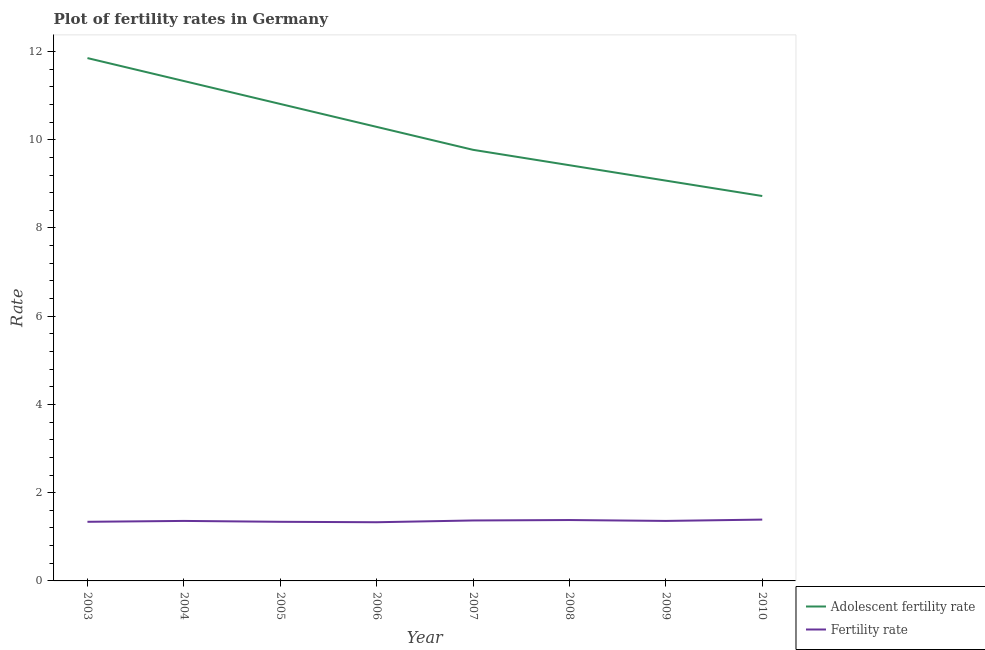How many different coloured lines are there?
Make the answer very short. 2. Is the number of lines equal to the number of legend labels?
Make the answer very short. Yes. What is the adolescent fertility rate in 2008?
Your answer should be compact. 9.42. Across all years, what is the maximum adolescent fertility rate?
Ensure brevity in your answer.  11.85. Across all years, what is the minimum adolescent fertility rate?
Offer a very short reply. 8.72. In which year was the fertility rate maximum?
Keep it short and to the point. 2010. In which year was the adolescent fertility rate minimum?
Make the answer very short. 2010. What is the total fertility rate in the graph?
Your answer should be very brief. 10.87. What is the difference between the adolescent fertility rate in 2005 and that in 2009?
Provide a short and direct response. 1.74. What is the difference between the adolescent fertility rate in 2003 and the fertility rate in 2008?
Ensure brevity in your answer.  10.47. What is the average adolescent fertility rate per year?
Keep it short and to the point. 10.16. In the year 2008, what is the difference between the adolescent fertility rate and fertility rate?
Your response must be concise. 8.04. In how many years, is the adolescent fertility rate greater than 6.8?
Ensure brevity in your answer.  8. What is the ratio of the adolescent fertility rate in 2004 to that in 2010?
Offer a terse response. 1.3. What is the difference between the highest and the second highest adolescent fertility rate?
Give a very brief answer. 0.52. What is the difference between the highest and the lowest adolescent fertility rate?
Offer a very short reply. 3.13. Is the sum of the fertility rate in 2008 and 2009 greater than the maximum adolescent fertility rate across all years?
Your response must be concise. No. Is the fertility rate strictly less than the adolescent fertility rate over the years?
Provide a succinct answer. Yes. Are the values on the major ticks of Y-axis written in scientific E-notation?
Your response must be concise. No. Does the graph contain any zero values?
Make the answer very short. No. What is the title of the graph?
Keep it short and to the point. Plot of fertility rates in Germany. Does "Girls" appear as one of the legend labels in the graph?
Ensure brevity in your answer.  No. What is the label or title of the X-axis?
Offer a terse response. Year. What is the label or title of the Y-axis?
Ensure brevity in your answer.  Rate. What is the Rate in Adolescent fertility rate in 2003?
Offer a very short reply. 11.85. What is the Rate in Fertility rate in 2003?
Keep it short and to the point. 1.34. What is the Rate of Adolescent fertility rate in 2004?
Offer a terse response. 11.33. What is the Rate of Fertility rate in 2004?
Ensure brevity in your answer.  1.36. What is the Rate in Adolescent fertility rate in 2005?
Offer a very short reply. 10.81. What is the Rate in Fertility rate in 2005?
Your answer should be very brief. 1.34. What is the Rate of Adolescent fertility rate in 2006?
Give a very brief answer. 10.29. What is the Rate of Fertility rate in 2006?
Provide a succinct answer. 1.33. What is the Rate in Adolescent fertility rate in 2007?
Ensure brevity in your answer.  9.77. What is the Rate in Fertility rate in 2007?
Offer a very short reply. 1.37. What is the Rate in Adolescent fertility rate in 2008?
Your response must be concise. 9.42. What is the Rate of Fertility rate in 2008?
Make the answer very short. 1.38. What is the Rate in Adolescent fertility rate in 2009?
Provide a short and direct response. 9.07. What is the Rate in Fertility rate in 2009?
Ensure brevity in your answer.  1.36. What is the Rate in Adolescent fertility rate in 2010?
Make the answer very short. 8.72. What is the Rate of Fertility rate in 2010?
Ensure brevity in your answer.  1.39. Across all years, what is the maximum Rate of Adolescent fertility rate?
Your response must be concise. 11.85. Across all years, what is the maximum Rate of Fertility rate?
Give a very brief answer. 1.39. Across all years, what is the minimum Rate of Adolescent fertility rate?
Offer a terse response. 8.72. Across all years, what is the minimum Rate in Fertility rate?
Provide a short and direct response. 1.33. What is the total Rate of Adolescent fertility rate in the graph?
Your answer should be very brief. 81.27. What is the total Rate of Fertility rate in the graph?
Ensure brevity in your answer.  10.87. What is the difference between the Rate in Adolescent fertility rate in 2003 and that in 2004?
Provide a succinct answer. 0.52. What is the difference between the Rate in Fertility rate in 2003 and that in 2004?
Provide a succinct answer. -0.02. What is the difference between the Rate of Adolescent fertility rate in 2003 and that in 2005?
Provide a short and direct response. 1.04. What is the difference between the Rate of Fertility rate in 2003 and that in 2005?
Provide a succinct answer. 0. What is the difference between the Rate of Adolescent fertility rate in 2003 and that in 2006?
Provide a succinct answer. 1.56. What is the difference between the Rate in Fertility rate in 2003 and that in 2006?
Offer a very short reply. 0.01. What is the difference between the Rate of Adolescent fertility rate in 2003 and that in 2007?
Keep it short and to the point. 2.08. What is the difference between the Rate in Fertility rate in 2003 and that in 2007?
Make the answer very short. -0.03. What is the difference between the Rate of Adolescent fertility rate in 2003 and that in 2008?
Your answer should be very brief. 2.43. What is the difference between the Rate in Fertility rate in 2003 and that in 2008?
Make the answer very short. -0.04. What is the difference between the Rate in Adolescent fertility rate in 2003 and that in 2009?
Your answer should be compact. 2.78. What is the difference between the Rate of Fertility rate in 2003 and that in 2009?
Provide a short and direct response. -0.02. What is the difference between the Rate in Adolescent fertility rate in 2003 and that in 2010?
Provide a short and direct response. 3.13. What is the difference between the Rate of Adolescent fertility rate in 2004 and that in 2005?
Make the answer very short. 0.52. What is the difference between the Rate of Adolescent fertility rate in 2004 and that in 2006?
Give a very brief answer. 1.04. What is the difference between the Rate of Adolescent fertility rate in 2004 and that in 2007?
Offer a very short reply. 1.56. What is the difference between the Rate of Fertility rate in 2004 and that in 2007?
Your response must be concise. -0.01. What is the difference between the Rate of Adolescent fertility rate in 2004 and that in 2008?
Keep it short and to the point. 1.91. What is the difference between the Rate in Fertility rate in 2004 and that in 2008?
Provide a short and direct response. -0.02. What is the difference between the Rate of Adolescent fertility rate in 2004 and that in 2009?
Keep it short and to the point. 2.26. What is the difference between the Rate of Fertility rate in 2004 and that in 2009?
Your answer should be very brief. 0. What is the difference between the Rate in Adolescent fertility rate in 2004 and that in 2010?
Your answer should be very brief. 2.61. What is the difference between the Rate of Fertility rate in 2004 and that in 2010?
Make the answer very short. -0.03. What is the difference between the Rate in Adolescent fertility rate in 2005 and that in 2006?
Your answer should be very brief. 0.52. What is the difference between the Rate of Fertility rate in 2005 and that in 2006?
Provide a succinct answer. 0.01. What is the difference between the Rate of Adolescent fertility rate in 2005 and that in 2007?
Your response must be concise. 1.04. What is the difference between the Rate in Fertility rate in 2005 and that in 2007?
Provide a short and direct response. -0.03. What is the difference between the Rate in Adolescent fertility rate in 2005 and that in 2008?
Make the answer very short. 1.39. What is the difference between the Rate in Fertility rate in 2005 and that in 2008?
Give a very brief answer. -0.04. What is the difference between the Rate of Adolescent fertility rate in 2005 and that in 2009?
Your answer should be very brief. 1.74. What is the difference between the Rate in Fertility rate in 2005 and that in 2009?
Make the answer very short. -0.02. What is the difference between the Rate in Adolescent fertility rate in 2005 and that in 2010?
Provide a succinct answer. 2.09. What is the difference between the Rate of Fertility rate in 2005 and that in 2010?
Provide a short and direct response. -0.05. What is the difference between the Rate in Adolescent fertility rate in 2006 and that in 2007?
Ensure brevity in your answer.  0.52. What is the difference between the Rate in Fertility rate in 2006 and that in 2007?
Your answer should be very brief. -0.04. What is the difference between the Rate in Adolescent fertility rate in 2006 and that in 2008?
Your response must be concise. 0.87. What is the difference between the Rate of Adolescent fertility rate in 2006 and that in 2009?
Give a very brief answer. 1.22. What is the difference between the Rate of Fertility rate in 2006 and that in 2009?
Give a very brief answer. -0.03. What is the difference between the Rate of Adolescent fertility rate in 2006 and that in 2010?
Make the answer very short. 1.57. What is the difference between the Rate of Fertility rate in 2006 and that in 2010?
Your answer should be compact. -0.06. What is the difference between the Rate of Adolescent fertility rate in 2007 and that in 2008?
Provide a succinct answer. 0.35. What is the difference between the Rate in Fertility rate in 2007 and that in 2008?
Provide a succinct answer. -0.01. What is the difference between the Rate in Adolescent fertility rate in 2007 and that in 2009?
Keep it short and to the point. 0.7. What is the difference between the Rate in Adolescent fertility rate in 2007 and that in 2010?
Your answer should be compact. 1.05. What is the difference between the Rate of Fertility rate in 2007 and that in 2010?
Offer a terse response. -0.02. What is the difference between the Rate in Adolescent fertility rate in 2008 and that in 2009?
Provide a succinct answer. 0.35. What is the difference between the Rate of Adolescent fertility rate in 2008 and that in 2010?
Your response must be concise. 0.7. What is the difference between the Rate in Fertility rate in 2008 and that in 2010?
Provide a succinct answer. -0.01. What is the difference between the Rate of Adolescent fertility rate in 2009 and that in 2010?
Offer a very short reply. 0.35. What is the difference between the Rate in Fertility rate in 2009 and that in 2010?
Make the answer very short. -0.03. What is the difference between the Rate of Adolescent fertility rate in 2003 and the Rate of Fertility rate in 2004?
Provide a short and direct response. 10.49. What is the difference between the Rate in Adolescent fertility rate in 2003 and the Rate in Fertility rate in 2005?
Keep it short and to the point. 10.51. What is the difference between the Rate of Adolescent fertility rate in 2003 and the Rate of Fertility rate in 2006?
Your answer should be very brief. 10.52. What is the difference between the Rate of Adolescent fertility rate in 2003 and the Rate of Fertility rate in 2007?
Keep it short and to the point. 10.48. What is the difference between the Rate in Adolescent fertility rate in 2003 and the Rate in Fertility rate in 2008?
Ensure brevity in your answer.  10.47. What is the difference between the Rate in Adolescent fertility rate in 2003 and the Rate in Fertility rate in 2009?
Make the answer very short. 10.49. What is the difference between the Rate in Adolescent fertility rate in 2003 and the Rate in Fertility rate in 2010?
Your answer should be very brief. 10.46. What is the difference between the Rate in Adolescent fertility rate in 2004 and the Rate in Fertility rate in 2005?
Offer a terse response. 9.99. What is the difference between the Rate in Adolescent fertility rate in 2004 and the Rate in Fertility rate in 2006?
Make the answer very short. 10. What is the difference between the Rate of Adolescent fertility rate in 2004 and the Rate of Fertility rate in 2007?
Offer a very short reply. 9.96. What is the difference between the Rate of Adolescent fertility rate in 2004 and the Rate of Fertility rate in 2008?
Offer a terse response. 9.95. What is the difference between the Rate in Adolescent fertility rate in 2004 and the Rate in Fertility rate in 2009?
Offer a very short reply. 9.97. What is the difference between the Rate of Adolescent fertility rate in 2004 and the Rate of Fertility rate in 2010?
Provide a short and direct response. 9.94. What is the difference between the Rate in Adolescent fertility rate in 2005 and the Rate in Fertility rate in 2006?
Your response must be concise. 9.48. What is the difference between the Rate of Adolescent fertility rate in 2005 and the Rate of Fertility rate in 2007?
Ensure brevity in your answer.  9.44. What is the difference between the Rate in Adolescent fertility rate in 2005 and the Rate in Fertility rate in 2008?
Make the answer very short. 9.43. What is the difference between the Rate of Adolescent fertility rate in 2005 and the Rate of Fertility rate in 2009?
Provide a succinct answer. 9.45. What is the difference between the Rate of Adolescent fertility rate in 2005 and the Rate of Fertility rate in 2010?
Provide a short and direct response. 9.42. What is the difference between the Rate in Adolescent fertility rate in 2006 and the Rate in Fertility rate in 2007?
Your response must be concise. 8.92. What is the difference between the Rate in Adolescent fertility rate in 2006 and the Rate in Fertility rate in 2008?
Keep it short and to the point. 8.91. What is the difference between the Rate of Adolescent fertility rate in 2006 and the Rate of Fertility rate in 2009?
Offer a very short reply. 8.93. What is the difference between the Rate in Adolescent fertility rate in 2006 and the Rate in Fertility rate in 2010?
Ensure brevity in your answer.  8.9. What is the difference between the Rate in Adolescent fertility rate in 2007 and the Rate in Fertility rate in 2008?
Your answer should be very brief. 8.39. What is the difference between the Rate of Adolescent fertility rate in 2007 and the Rate of Fertility rate in 2009?
Offer a terse response. 8.41. What is the difference between the Rate in Adolescent fertility rate in 2007 and the Rate in Fertility rate in 2010?
Offer a terse response. 8.38. What is the difference between the Rate of Adolescent fertility rate in 2008 and the Rate of Fertility rate in 2009?
Your response must be concise. 8.06. What is the difference between the Rate of Adolescent fertility rate in 2008 and the Rate of Fertility rate in 2010?
Give a very brief answer. 8.03. What is the difference between the Rate in Adolescent fertility rate in 2009 and the Rate in Fertility rate in 2010?
Your answer should be very brief. 7.68. What is the average Rate in Adolescent fertility rate per year?
Offer a terse response. 10.16. What is the average Rate in Fertility rate per year?
Provide a succinct answer. 1.36. In the year 2003, what is the difference between the Rate of Adolescent fertility rate and Rate of Fertility rate?
Make the answer very short. 10.51. In the year 2004, what is the difference between the Rate of Adolescent fertility rate and Rate of Fertility rate?
Your answer should be very brief. 9.97. In the year 2005, what is the difference between the Rate in Adolescent fertility rate and Rate in Fertility rate?
Your answer should be very brief. 9.47. In the year 2006, what is the difference between the Rate of Adolescent fertility rate and Rate of Fertility rate?
Offer a terse response. 8.96. In the year 2007, what is the difference between the Rate of Adolescent fertility rate and Rate of Fertility rate?
Provide a short and direct response. 8.4. In the year 2008, what is the difference between the Rate in Adolescent fertility rate and Rate in Fertility rate?
Provide a short and direct response. 8.04. In the year 2009, what is the difference between the Rate of Adolescent fertility rate and Rate of Fertility rate?
Make the answer very short. 7.71. In the year 2010, what is the difference between the Rate of Adolescent fertility rate and Rate of Fertility rate?
Keep it short and to the point. 7.33. What is the ratio of the Rate of Adolescent fertility rate in 2003 to that in 2004?
Ensure brevity in your answer.  1.05. What is the ratio of the Rate in Fertility rate in 2003 to that in 2004?
Provide a succinct answer. 0.99. What is the ratio of the Rate of Adolescent fertility rate in 2003 to that in 2005?
Provide a short and direct response. 1.1. What is the ratio of the Rate of Adolescent fertility rate in 2003 to that in 2006?
Provide a short and direct response. 1.15. What is the ratio of the Rate of Fertility rate in 2003 to that in 2006?
Provide a short and direct response. 1.01. What is the ratio of the Rate in Adolescent fertility rate in 2003 to that in 2007?
Offer a terse response. 1.21. What is the ratio of the Rate of Fertility rate in 2003 to that in 2007?
Offer a terse response. 0.98. What is the ratio of the Rate in Adolescent fertility rate in 2003 to that in 2008?
Your response must be concise. 1.26. What is the ratio of the Rate in Fertility rate in 2003 to that in 2008?
Ensure brevity in your answer.  0.97. What is the ratio of the Rate of Adolescent fertility rate in 2003 to that in 2009?
Keep it short and to the point. 1.31. What is the ratio of the Rate in Fertility rate in 2003 to that in 2009?
Ensure brevity in your answer.  0.99. What is the ratio of the Rate in Adolescent fertility rate in 2003 to that in 2010?
Give a very brief answer. 1.36. What is the ratio of the Rate of Adolescent fertility rate in 2004 to that in 2005?
Give a very brief answer. 1.05. What is the ratio of the Rate of Fertility rate in 2004 to that in 2005?
Offer a terse response. 1.01. What is the ratio of the Rate of Adolescent fertility rate in 2004 to that in 2006?
Ensure brevity in your answer.  1.1. What is the ratio of the Rate in Fertility rate in 2004 to that in 2006?
Offer a very short reply. 1.02. What is the ratio of the Rate of Adolescent fertility rate in 2004 to that in 2007?
Your answer should be compact. 1.16. What is the ratio of the Rate of Adolescent fertility rate in 2004 to that in 2008?
Your answer should be very brief. 1.2. What is the ratio of the Rate in Fertility rate in 2004 to that in 2008?
Your answer should be compact. 0.99. What is the ratio of the Rate of Adolescent fertility rate in 2004 to that in 2009?
Provide a succinct answer. 1.25. What is the ratio of the Rate of Adolescent fertility rate in 2004 to that in 2010?
Make the answer very short. 1.3. What is the ratio of the Rate of Fertility rate in 2004 to that in 2010?
Offer a very short reply. 0.98. What is the ratio of the Rate in Adolescent fertility rate in 2005 to that in 2006?
Provide a succinct answer. 1.05. What is the ratio of the Rate of Fertility rate in 2005 to that in 2006?
Your response must be concise. 1.01. What is the ratio of the Rate in Adolescent fertility rate in 2005 to that in 2007?
Offer a terse response. 1.11. What is the ratio of the Rate in Fertility rate in 2005 to that in 2007?
Make the answer very short. 0.98. What is the ratio of the Rate in Adolescent fertility rate in 2005 to that in 2008?
Offer a very short reply. 1.15. What is the ratio of the Rate of Adolescent fertility rate in 2005 to that in 2009?
Provide a short and direct response. 1.19. What is the ratio of the Rate of Adolescent fertility rate in 2005 to that in 2010?
Offer a very short reply. 1.24. What is the ratio of the Rate of Adolescent fertility rate in 2006 to that in 2007?
Give a very brief answer. 1.05. What is the ratio of the Rate of Fertility rate in 2006 to that in 2007?
Provide a short and direct response. 0.97. What is the ratio of the Rate in Adolescent fertility rate in 2006 to that in 2008?
Your response must be concise. 1.09. What is the ratio of the Rate in Fertility rate in 2006 to that in 2008?
Offer a very short reply. 0.96. What is the ratio of the Rate of Adolescent fertility rate in 2006 to that in 2009?
Your answer should be very brief. 1.13. What is the ratio of the Rate in Fertility rate in 2006 to that in 2009?
Give a very brief answer. 0.98. What is the ratio of the Rate in Adolescent fertility rate in 2006 to that in 2010?
Ensure brevity in your answer.  1.18. What is the ratio of the Rate in Fertility rate in 2006 to that in 2010?
Your answer should be compact. 0.96. What is the ratio of the Rate in Adolescent fertility rate in 2007 to that in 2008?
Offer a very short reply. 1.04. What is the ratio of the Rate of Fertility rate in 2007 to that in 2008?
Your response must be concise. 0.99. What is the ratio of the Rate of Fertility rate in 2007 to that in 2009?
Your answer should be compact. 1.01. What is the ratio of the Rate in Adolescent fertility rate in 2007 to that in 2010?
Make the answer very short. 1.12. What is the ratio of the Rate in Fertility rate in 2007 to that in 2010?
Provide a short and direct response. 0.99. What is the ratio of the Rate in Adolescent fertility rate in 2008 to that in 2009?
Provide a succinct answer. 1.04. What is the ratio of the Rate of Fertility rate in 2008 to that in 2009?
Keep it short and to the point. 1.01. What is the ratio of the Rate in Fertility rate in 2009 to that in 2010?
Offer a terse response. 0.98. What is the difference between the highest and the second highest Rate in Adolescent fertility rate?
Provide a short and direct response. 0.52. What is the difference between the highest and the second highest Rate of Fertility rate?
Provide a short and direct response. 0.01. What is the difference between the highest and the lowest Rate of Adolescent fertility rate?
Your answer should be very brief. 3.13. 